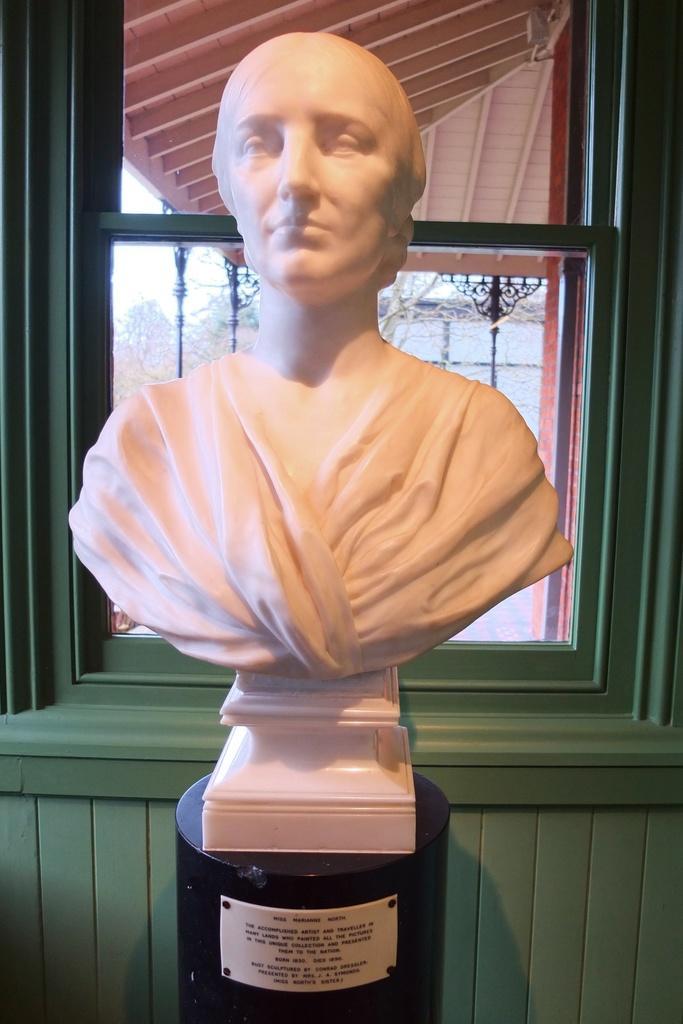Could you give a brief overview of what you see in this image? This picture contains a statue of the woman which is placed on the black color box. Behind that, we see a green wall and a window from which we can see poles and trees. At the top of the picture, we see the roof of the room. 